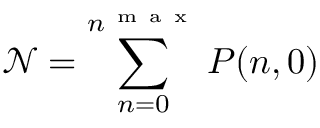<formula> <loc_0><loc_0><loc_500><loc_500>\mathcal { N } = \sum _ { n = 0 } ^ { n ^ { m a x } } P ( n , 0 )</formula> 